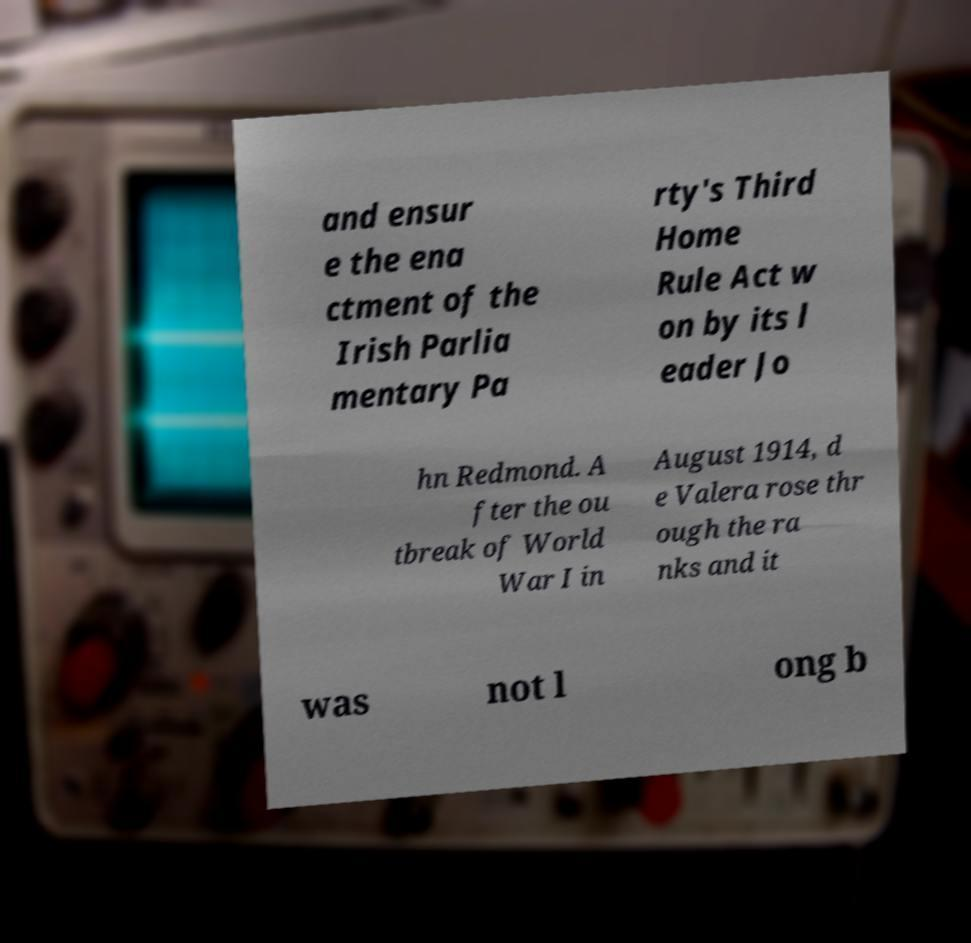I need the written content from this picture converted into text. Can you do that? and ensur e the ena ctment of the Irish Parlia mentary Pa rty's Third Home Rule Act w on by its l eader Jo hn Redmond. A fter the ou tbreak of World War I in August 1914, d e Valera rose thr ough the ra nks and it was not l ong b 